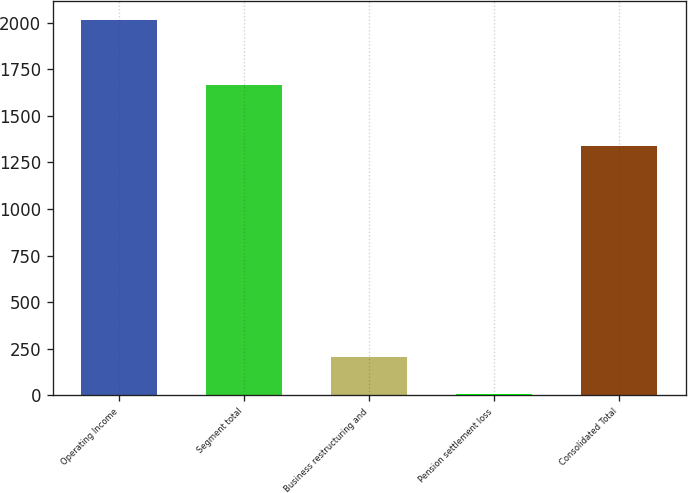Convert chart to OTSL. <chart><loc_0><loc_0><loc_500><loc_500><bar_chart><fcel>Operating Income<fcel>Segment total<fcel>Business restructuring and<fcel>Pension settlement loss<fcel>Consolidated Total<nl><fcel>2014<fcel>1667.4<fcel>206.35<fcel>5.5<fcel>1339.1<nl></chart> 